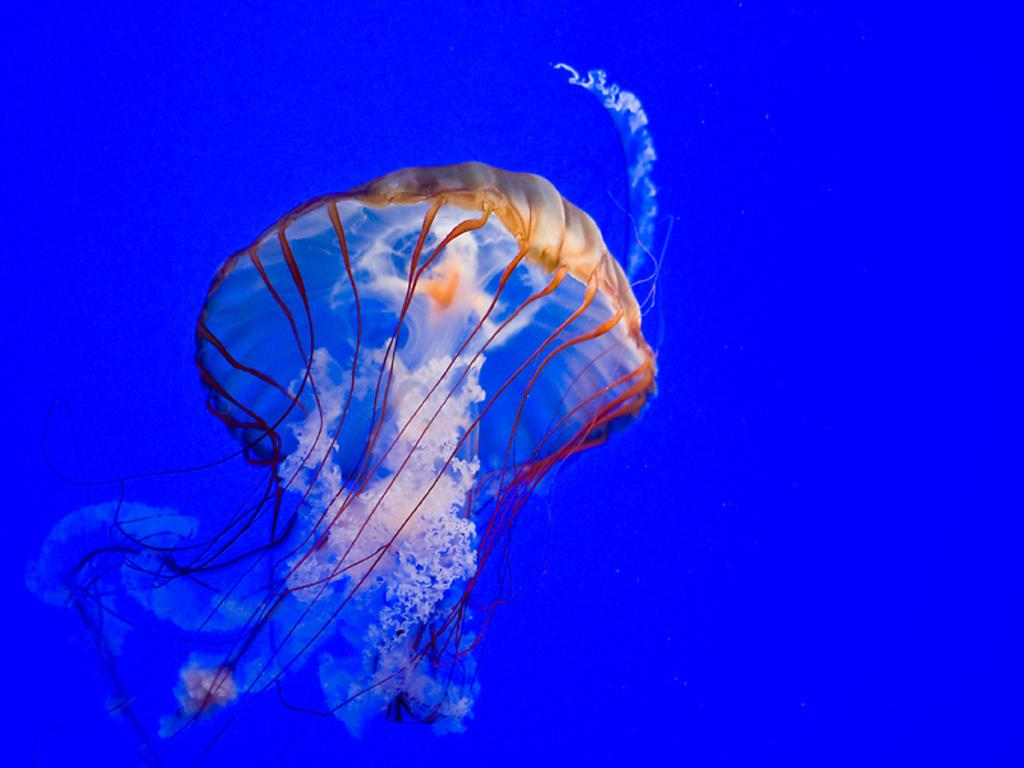What type of animal can be seen in the water in the image? There is a jellyfish in the water in the image. What color is the background of the image? The background of the image is blue in color. What type of reaction can be seen from the jellyfish in the image? There is no reaction visible from the jellyfish in the image, as it is a non-sentient marine animal. Is there a knife present in the image? There is no knife present in the image. 